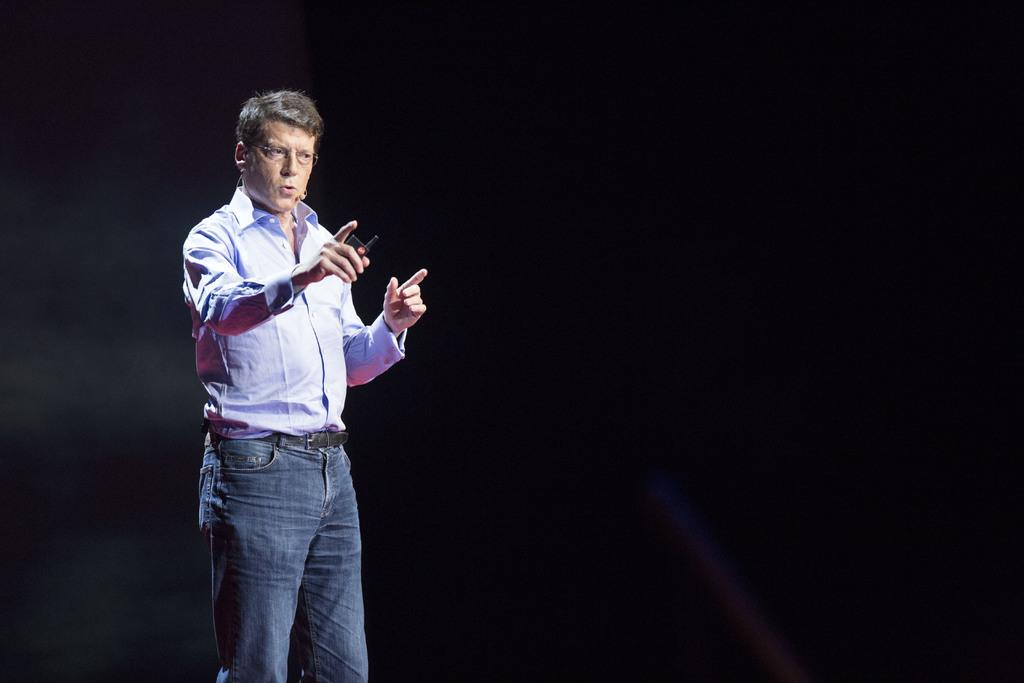Who is the main subject in the image? There is a man in the image. Where is the man located in the image? The man is standing in the middle of the image. What is the man holding in the image? The man is holding an electronic device. What type of beam is the man using to support the electronic device in the image? There is no beam present in the image, and the man is not using any support to hold the electronic device. 